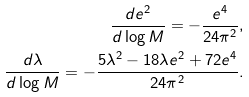Convert formula to latex. <formula><loc_0><loc_0><loc_500><loc_500>\frac { d e ^ { 2 } } { d \log M } = - \frac { e ^ { 4 } } { 2 4 \pi ^ { 2 } } , \\ \frac { d \lambda } { d \log M } = - \frac { 5 \lambda ^ { 2 } - 1 8 \lambda e ^ { 2 } + 7 2 e ^ { 4 } } { 2 4 \pi ^ { 2 } } .</formula> 